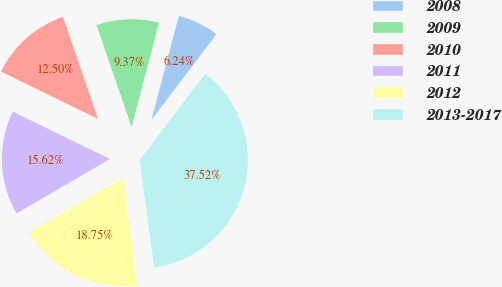<chart> <loc_0><loc_0><loc_500><loc_500><pie_chart><fcel>2008<fcel>2009<fcel>2010<fcel>2011<fcel>2012<fcel>2013-2017<nl><fcel>6.24%<fcel>9.37%<fcel>12.5%<fcel>15.62%<fcel>18.75%<fcel>37.52%<nl></chart> 